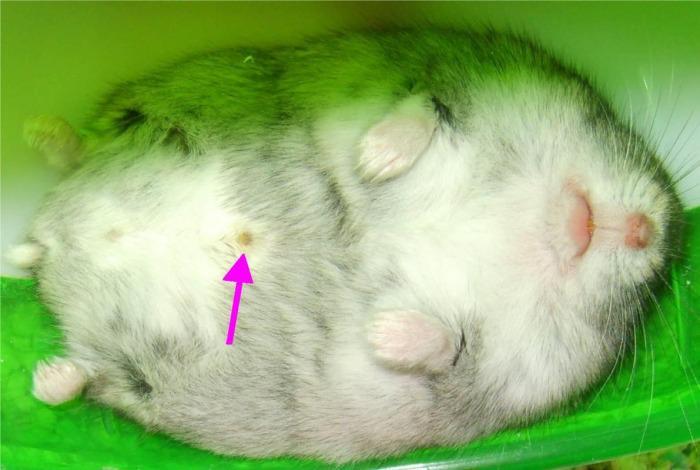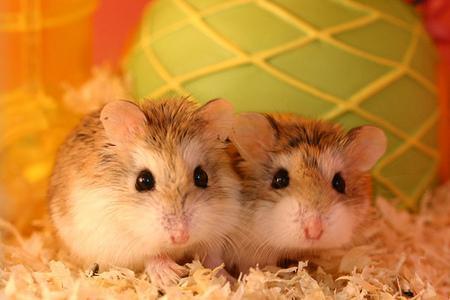The first image is the image on the left, the second image is the image on the right. Assess this claim about the two images: "One image shows side-by-side hamsters, and the other shows one small pet in an upturned palm.". Correct or not? Answer yes or no. No. The first image is the image on the left, the second image is the image on the right. Evaluate the accuracy of this statement regarding the images: "The right image contains at least two hamsters.". Is it true? Answer yes or no. Yes. 